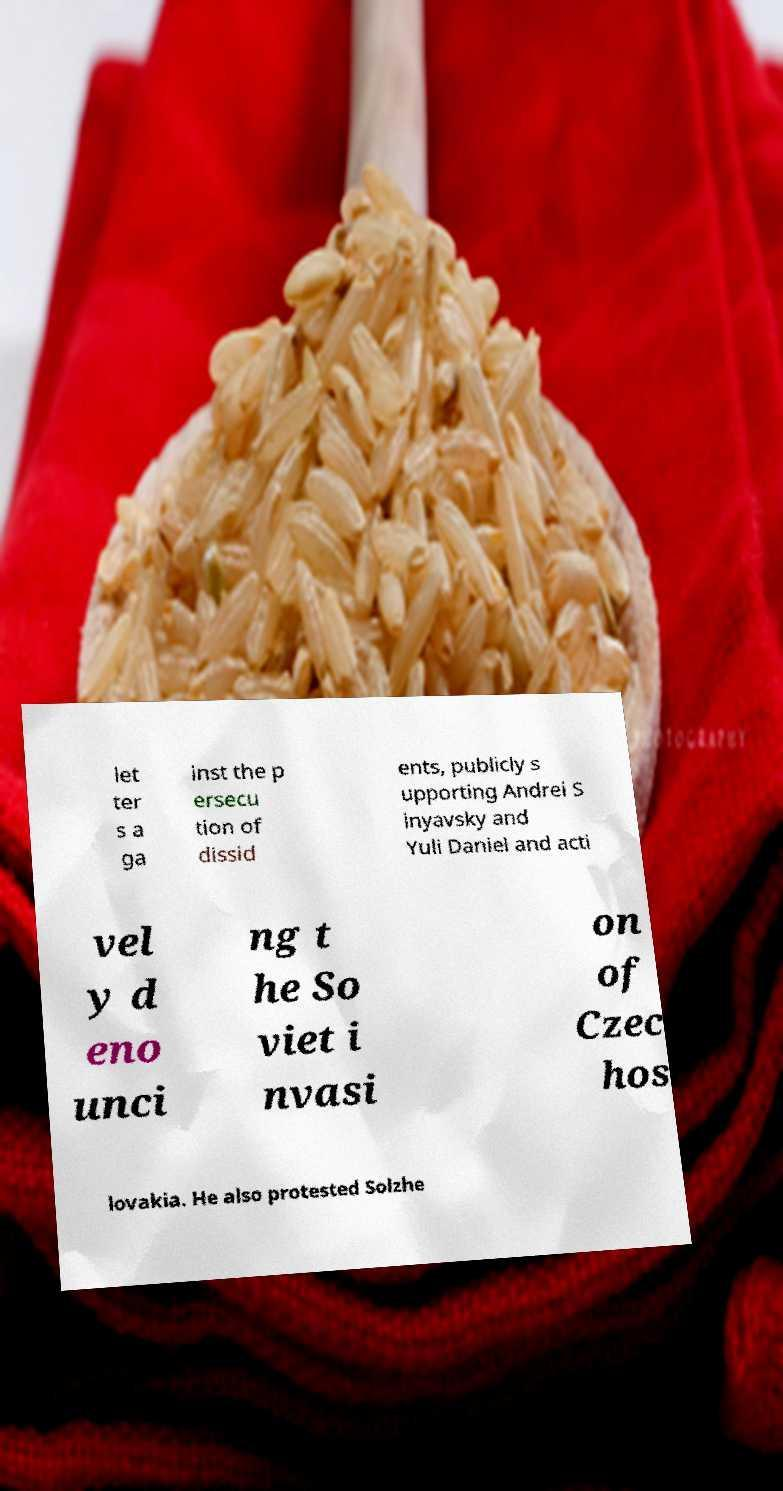Could you extract and type out the text from this image? let ter s a ga inst the p ersecu tion of dissid ents, publicly s upporting Andrei S inyavsky and Yuli Daniel and acti vel y d eno unci ng t he So viet i nvasi on of Czec hos lovakia. He also protested Solzhe 